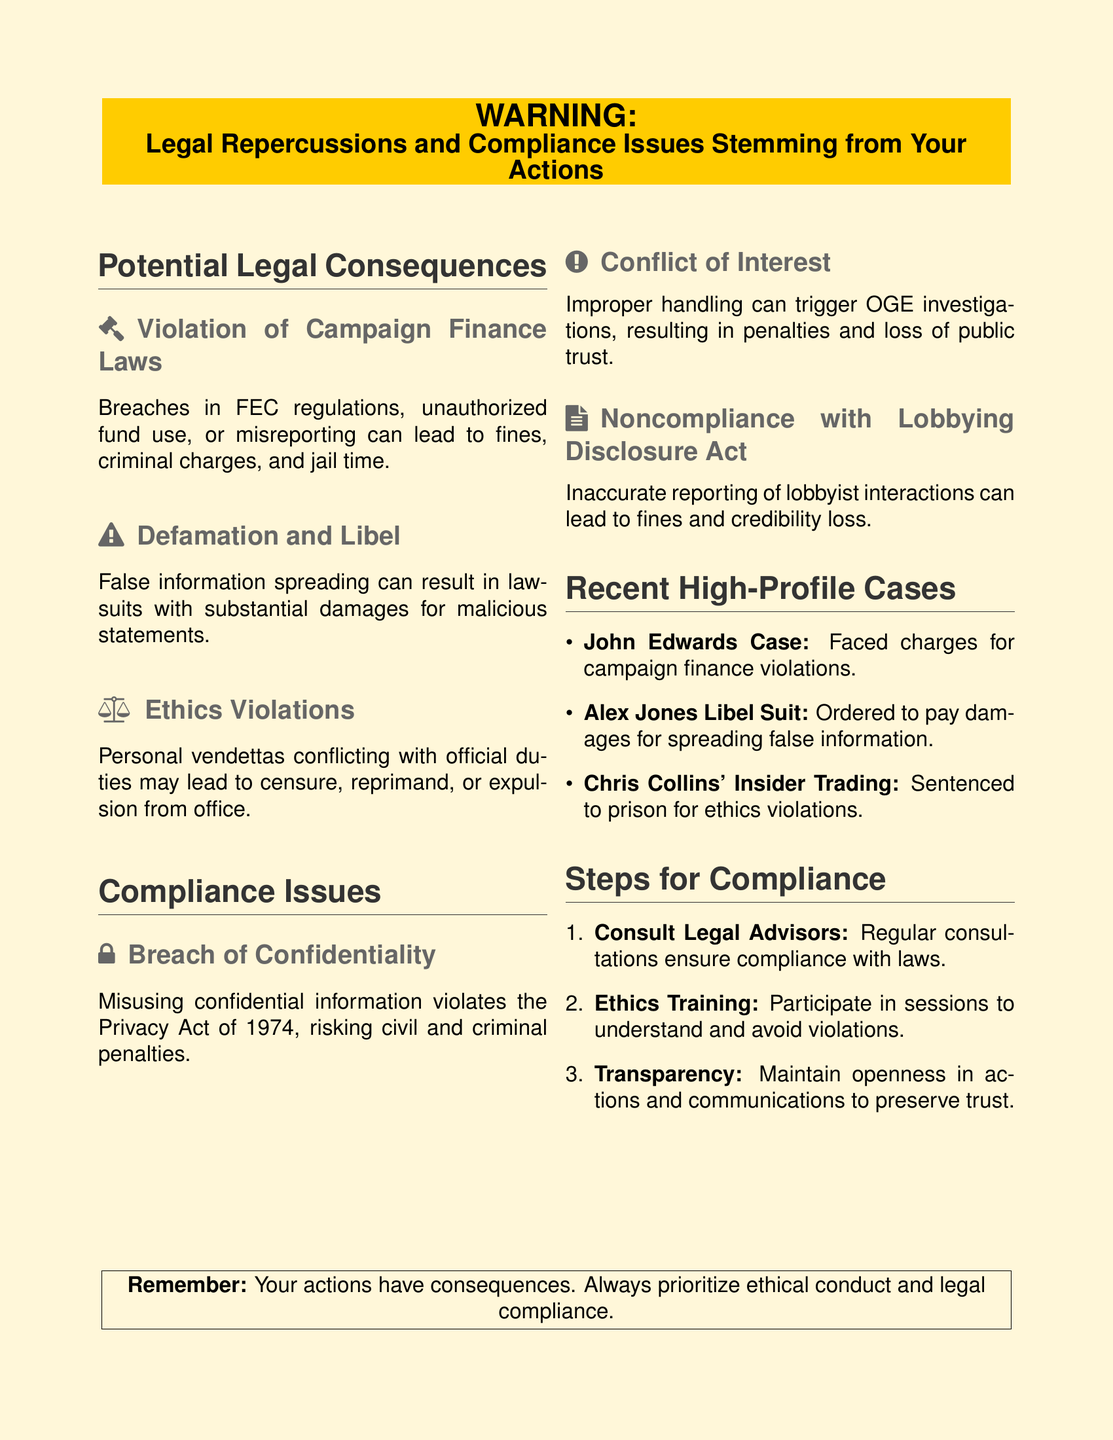What can result from violating campaign finance laws? Violating campaign finance laws can lead to fines, criminal charges, and jail time.
Answer: Fines, criminal charges, and jail time What is a potential consequence of spreading false information? Spreading false information can result in lawsuits with substantial damages for malicious statements.
Answer: Lawsuits with substantial damages What can breach of confidentiality lead to? Breach of confidentiality can lead to civil and criminal penalties.
Answer: Civil and criminal penalties Who faced charges for campaign finance violations? John Edwards faced charges for campaign finance violations.
Answer: John Edwards What is one of the steps for compliance listed in the document? One of the steps for compliance is to consult legal advisors.
Answer: Consult legal advisors What does improper handling of conflicts of interest trigger? Improper handling can trigger OGE investigations.
Answer: OGE investigations What is the focus of the document? The focus of the document is on legal repercussions and compliance issues stemming from actions.
Answer: Legal repercussions and compliance issues What is the risk of noncompliance with the Lobbying Disclosure Act? Noncompliance can lead to fines and credibility loss.
Answer: Fines and credibility loss 